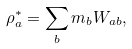<formula> <loc_0><loc_0><loc_500><loc_500>\rho _ { a } ^ { * } = \sum _ { b } m _ { b } W _ { a b } ,</formula> 